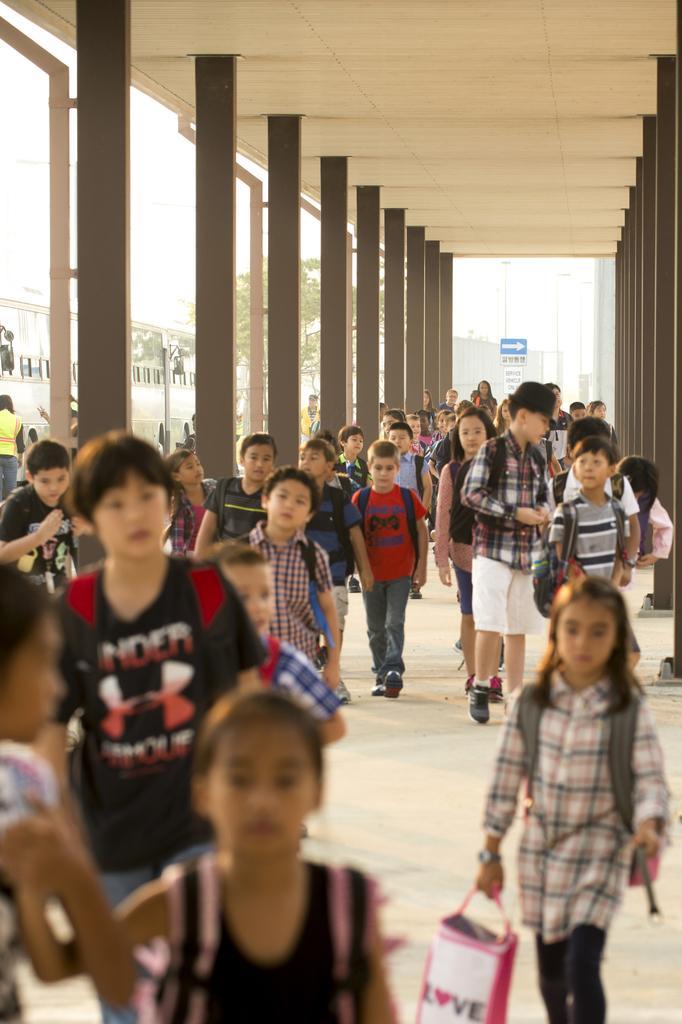How would you summarize this image in a sentence or two? In this picture I can see many children who are walking on the corridor. Beside them I can see the pillars. In the background I can see the sign boards, street lights, poles, trees and building. In the bottom right there is a girl who is holding a bag. In the top left corner I can see the sky. 